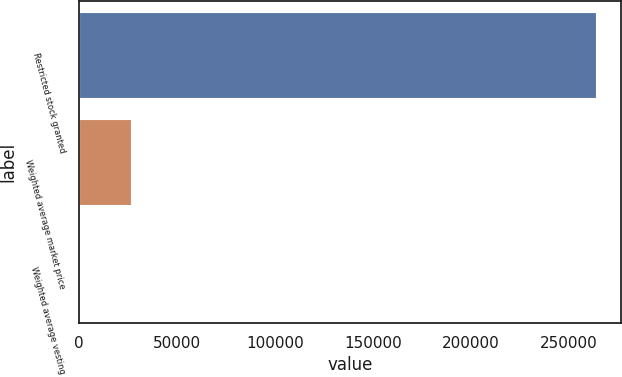Convert chart to OTSL. <chart><loc_0><loc_0><loc_500><loc_500><bar_chart><fcel>Restricted stock granted<fcel>Weighted average market price<fcel>Weighted average vesting<nl><fcel>263771<fcel>26379.9<fcel>3.09<nl></chart> 